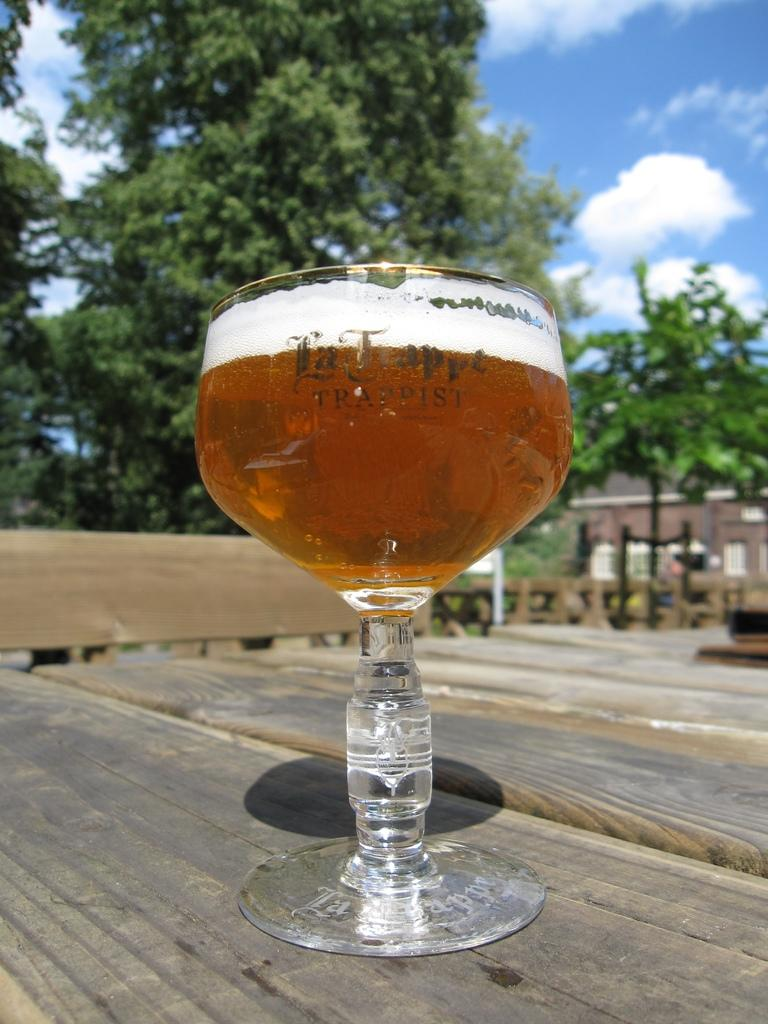What is in the glass that is visible in the image? There is a glass with liquid in the image. Where is the glass placed in the image? The glass is placed on a wooden surface. What can be seen in the background of the image? There is a building visible in the image, as well as trees and the sky. What is the condition of the sky in the image? The sky is visible in the image, and clouds are present. Can you tell me how many items are on the list in the image? There is no list present in the image. How does the quiet atmosphere in the image affect the mood of the scene? There is no mention of a quiet atmosphere or mood in the image. 